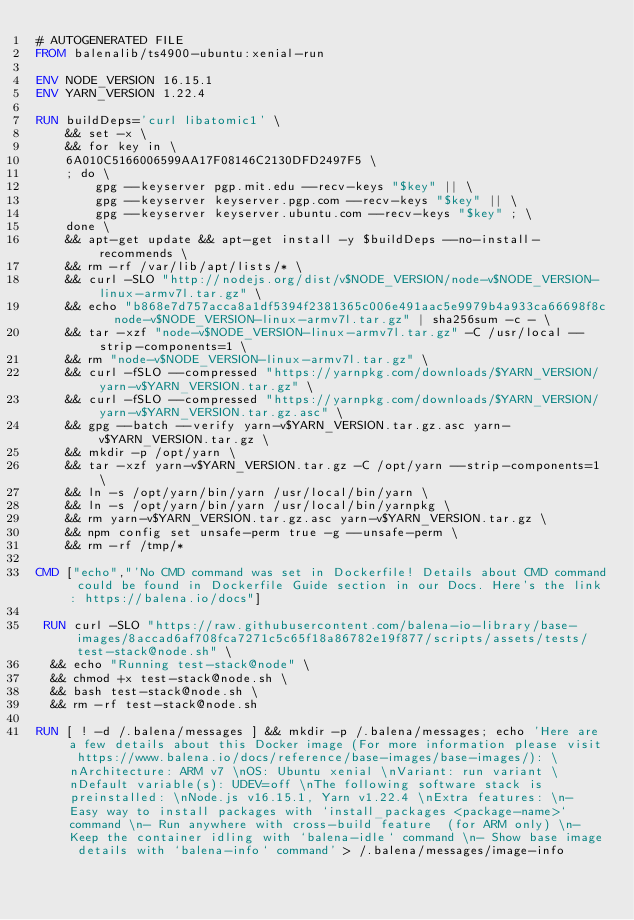Convert code to text. <code><loc_0><loc_0><loc_500><loc_500><_Dockerfile_># AUTOGENERATED FILE
FROM balenalib/ts4900-ubuntu:xenial-run

ENV NODE_VERSION 16.15.1
ENV YARN_VERSION 1.22.4

RUN buildDeps='curl libatomic1' \
	&& set -x \
	&& for key in \
	6A010C5166006599AA17F08146C2130DFD2497F5 \
	; do \
		gpg --keyserver pgp.mit.edu --recv-keys "$key" || \
		gpg --keyserver keyserver.pgp.com --recv-keys "$key" || \
		gpg --keyserver keyserver.ubuntu.com --recv-keys "$key" ; \
	done \
	&& apt-get update && apt-get install -y $buildDeps --no-install-recommends \
	&& rm -rf /var/lib/apt/lists/* \
	&& curl -SLO "http://nodejs.org/dist/v$NODE_VERSION/node-v$NODE_VERSION-linux-armv7l.tar.gz" \
	&& echo "b868e7d757acca8a1df5394f2381365c006e491aac5e9979b4a933ca66698f8c  node-v$NODE_VERSION-linux-armv7l.tar.gz" | sha256sum -c - \
	&& tar -xzf "node-v$NODE_VERSION-linux-armv7l.tar.gz" -C /usr/local --strip-components=1 \
	&& rm "node-v$NODE_VERSION-linux-armv7l.tar.gz" \
	&& curl -fSLO --compressed "https://yarnpkg.com/downloads/$YARN_VERSION/yarn-v$YARN_VERSION.tar.gz" \
	&& curl -fSLO --compressed "https://yarnpkg.com/downloads/$YARN_VERSION/yarn-v$YARN_VERSION.tar.gz.asc" \
	&& gpg --batch --verify yarn-v$YARN_VERSION.tar.gz.asc yarn-v$YARN_VERSION.tar.gz \
	&& mkdir -p /opt/yarn \
	&& tar -xzf yarn-v$YARN_VERSION.tar.gz -C /opt/yarn --strip-components=1 \
	&& ln -s /opt/yarn/bin/yarn /usr/local/bin/yarn \
	&& ln -s /opt/yarn/bin/yarn /usr/local/bin/yarnpkg \
	&& rm yarn-v$YARN_VERSION.tar.gz.asc yarn-v$YARN_VERSION.tar.gz \
	&& npm config set unsafe-perm true -g --unsafe-perm \
	&& rm -rf /tmp/*

CMD ["echo","'No CMD command was set in Dockerfile! Details about CMD command could be found in Dockerfile Guide section in our Docs. Here's the link: https://balena.io/docs"]

 RUN curl -SLO "https://raw.githubusercontent.com/balena-io-library/base-images/8accad6af708fca7271c5c65f18a86782e19f877/scripts/assets/tests/test-stack@node.sh" \
  && echo "Running test-stack@node" \
  && chmod +x test-stack@node.sh \
  && bash test-stack@node.sh \
  && rm -rf test-stack@node.sh 

RUN [ ! -d /.balena/messages ] && mkdir -p /.balena/messages; echo 'Here are a few details about this Docker image (For more information please visit https://www.balena.io/docs/reference/base-images/base-images/): \nArchitecture: ARM v7 \nOS: Ubuntu xenial \nVariant: run variant \nDefault variable(s): UDEV=off \nThe following software stack is preinstalled: \nNode.js v16.15.1, Yarn v1.22.4 \nExtra features: \n- Easy way to install packages with `install_packages <package-name>` command \n- Run anywhere with cross-build feature  (for ARM only) \n- Keep the container idling with `balena-idle` command \n- Show base image details with `balena-info` command' > /.balena/messages/image-info</code> 